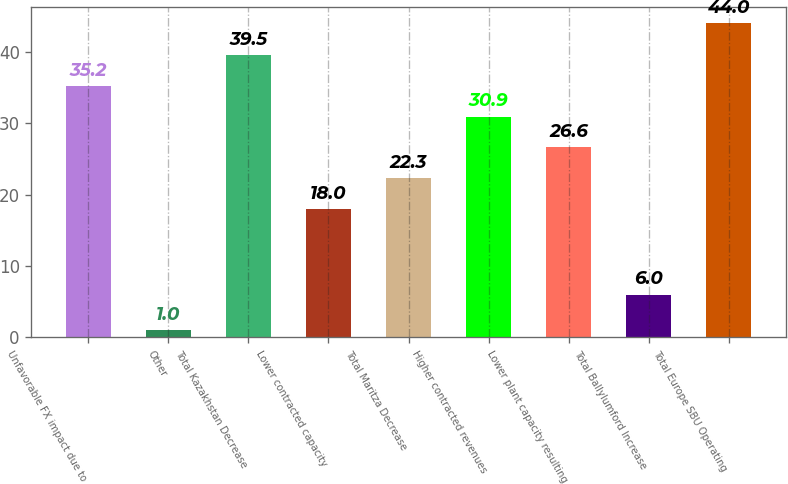<chart> <loc_0><loc_0><loc_500><loc_500><bar_chart><fcel>Unfavorable FX impact due to<fcel>Other<fcel>Total Kazakhstan Decrease<fcel>Lower contracted capacity<fcel>Total Maritza Decrease<fcel>Higher contracted revenues<fcel>Lower plant capacity resulting<fcel>Total Ballylumford Increase<fcel>Total Europe SBU Operating<nl><fcel>35.2<fcel>1<fcel>39.5<fcel>18<fcel>22.3<fcel>30.9<fcel>26.6<fcel>6<fcel>44<nl></chart> 